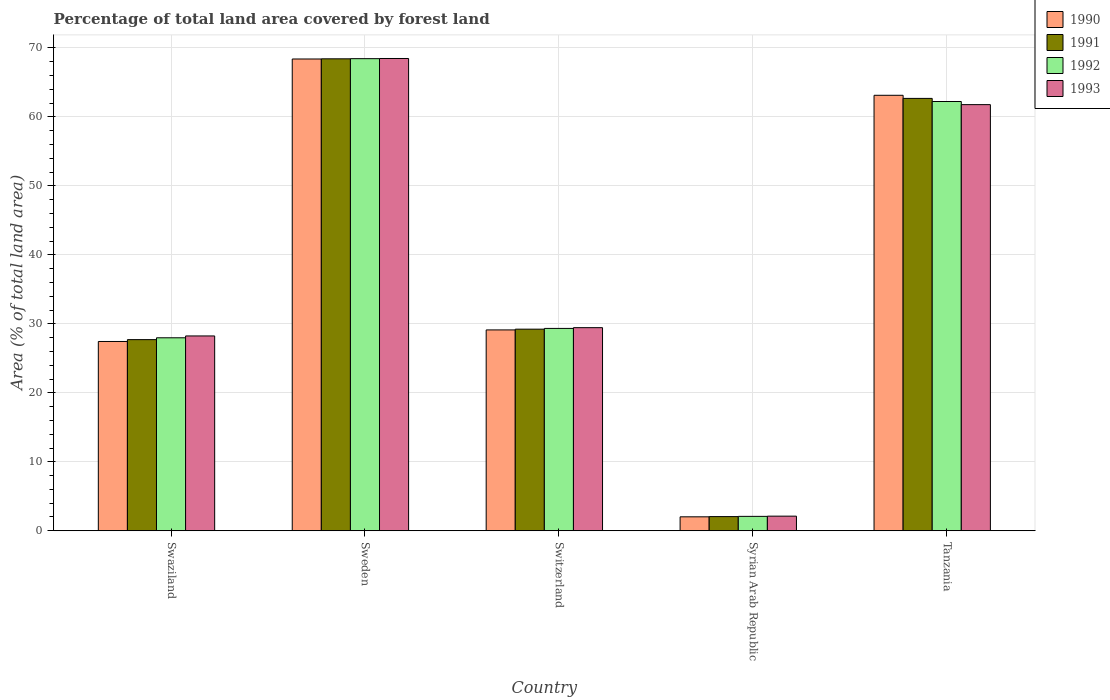How many different coloured bars are there?
Provide a succinct answer. 4. Are the number of bars per tick equal to the number of legend labels?
Offer a terse response. Yes. What is the label of the 2nd group of bars from the left?
Your answer should be compact. Sweden. In how many cases, is the number of bars for a given country not equal to the number of legend labels?
Provide a succinct answer. 0. What is the percentage of forest land in 1990 in Syrian Arab Republic?
Ensure brevity in your answer.  2.02. Across all countries, what is the maximum percentage of forest land in 1991?
Your response must be concise. 68.41. Across all countries, what is the minimum percentage of forest land in 1990?
Offer a terse response. 2.02. In which country was the percentage of forest land in 1993 minimum?
Give a very brief answer. Syrian Arab Republic. What is the total percentage of forest land in 1992 in the graph?
Your answer should be very brief. 190.07. What is the difference between the percentage of forest land in 1991 in Switzerland and that in Syrian Arab Republic?
Offer a very short reply. 27.17. What is the difference between the percentage of forest land in 1991 in Sweden and the percentage of forest land in 1990 in Switzerland?
Offer a very short reply. 39.3. What is the average percentage of forest land in 1990 per country?
Offer a very short reply. 38.02. What is the difference between the percentage of forest land of/in 1990 and percentage of forest land of/in 1992 in Swaziland?
Your response must be concise. -0.53. In how many countries, is the percentage of forest land in 1990 greater than 38 %?
Provide a short and direct response. 2. What is the ratio of the percentage of forest land in 1990 in Switzerland to that in Tanzania?
Your answer should be very brief. 0.46. Is the difference between the percentage of forest land in 1990 in Switzerland and Syrian Arab Republic greater than the difference between the percentage of forest land in 1992 in Switzerland and Syrian Arab Republic?
Your answer should be very brief. No. What is the difference between the highest and the second highest percentage of forest land in 1992?
Keep it short and to the point. 39.1. What is the difference between the highest and the lowest percentage of forest land in 1991?
Your answer should be compact. 66.36. Is it the case that in every country, the sum of the percentage of forest land in 1991 and percentage of forest land in 1993 is greater than the sum of percentage of forest land in 1990 and percentage of forest land in 1992?
Make the answer very short. No. What does the 2nd bar from the left in Tanzania represents?
Ensure brevity in your answer.  1991. What does the 2nd bar from the right in Syrian Arab Republic represents?
Your answer should be compact. 1992. Is it the case that in every country, the sum of the percentage of forest land in 1990 and percentage of forest land in 1991 is greater than the percentage of forest land in 1992?
Ensure brevity in your answer.  Yes. How many bars are there?
Keep it short and to the point. 20. How many countries are there in the graph?
Provide a succinct answer. 5. What is the difference between two consecutive major ticks on the Y-axis?
Make the answer very short. 10. Does the graph contain any zero values?
Offer a terse response. No. Where does the legend appear in the graph?
Your response must be concise. Top right. How are the legend labels stacked?
Provide a short and direct response. Vertical. What is the title of the graph?
Ensure brevity in your answer.  Percentage of total land area covered by forest land. What is the label or title of the X-axis?
Offer a very short reply. Country. What is the label or title of the Y-axis?
Provide a succinct answer. Area (% of total land area). What is the Area (% of total land area) in 1990 in Swaziland?
Ensure brevity in your answer.  27.44. What is the Area (% of total land area) of 1991 in Swaziland?
Give a very brief answer. 27.71. What is the Area (% of total land area) of 1992 in Swaziland?
Offer a very short reply. 27.98. What is the Area (% of total land area) of 1993 in Swaziland?
Your answer should be compact. 28.24. What is the Area (% of total land area) in 1990 in Sweden?
Offer a terse response. 68.39. What is the Area (% of total land area) of 1991 in Sweden?
Ensure brevity in your answer.  68.41. What is the Area (% of total land area) in 1992 in Sweden?
Keep it short and to the point. 68.44. What is the Area (% of total land area) in 1993 in Sweden?
Your answer should be very brief. 68.46. What is the Area (% of total land area) in 1990 in Switzerland?
Offer a very short reply. 29.12. What is the Area (% of total land area) of 1991 in Switzerland?
Your answer should be very brief. 29.23. What is the Area (% of total land area) in 1992 in Switzerland?
Your response must be concise. 29.34. What is the Area (% of total land area) of 1993 in Switzerland?
Offer a very short reply. 29.44. What is the Area (% of total land area) of 1990 in Syrian Arab Republic?
Provide a short and direct response. 2.02. What is the Area (% of total land area) of 1991 in Syrian Arab Republic?
Your answer should be compact. 2.06. What is the Area (% of total land area) of 1992 in Syrian Arab Republic?
Ensure brevity in your answer.  2.09. What is the Area (% of total land area) in 1993 in Syrian Arab Republic?
Offer a terse response. 2.12. What is the Area (% of total land area) of 1990 in Tanzania?
Offer a very short reply. 63.13. What is the Area (% of total land area) of 1991 in Tanzania?
Your response must be concise. 62.68. What is the Area (% of total land area) of 1992 in Tanzania?
Make the answer very short. 62.23. What is the Area (% of total land area) of 1993 in Tanzania?
Ensure brevity in your answer.  61.77. Across all countries, what is the maximum Area (% of total land area) of 1990?
Your answer should be compact. 68.39. Across all countries, what is the maximum Area (% of total land area) in 1991?
Your answer should be compact. 68.41. Across all countries, what is the maximum Area (% of total land area) in 1992?
Ensure brevity in your answer.  68.44. Across all countries, what is the maximum Area (% of total land area) of 1993?
Keep it short and to the point. 68.46. Across all countries, what is the minimum Area (% of total land area) of 1990?
Your answer should be very brief. 2.02. Across all countries, what is the minimum Area (% of total land area) in 1991?
Your answer should be compact. 2.06. Across all countries, what is the minimum Area (% of total land area) of 1992?
Offer a terse response. 2.09. Across all countries, what is the minimum Area (% of total land area) in 1993?
Your answer should be very brief. 2.12. What is the total Area (% of total land area) of 1990 in the graph?
Provide a succinct answer. 190.1. What is the total Area (% of total land area) of 1991 in the graph?
Ensure brevity in your answer.  190.08. What is the total Area (% of total land area) in 1992 in the graph?
Provide a short and direct response. 190.07. What is the total Area (% of total land area) in 1993 in the graph?
Your answer should be compact. 190.05. What is the difference between the Area (% of total land area) of 1990 in Swaziland and that in Sweden?
Your answer should be very brief. -40.95. What is the difference between the Area (% of total land area) of 1991 in Swaziland and that in Sweden?
Offer a terse response. -40.7. What is the difference between the Area (% of total land area) of 1992 in Swaziland and that in Sweden?
Offer a very short reply. -40.46. What is the difference between the Area (% of total land area) in 1993 in Swaziland and that in Sweden?
Provide a short and direct response. -40.22. What is the difference between the Area (% of total land area) of 1990 in Swaziland and that in Switzerland?
Provide a succinct answer. -1.68. What is the difference between the Area (% of total land area) of 1991 in Swaziland and that in Switzerland?
Offer a terse response. -1.52. What is the difference between the Area (% of total land area) of 1992 in Swaziland and that in Switzerland?
Your answer should be compact. -1.36. What is the difference between the Area (% of total land area) of 1993 in Swaziland and that in Switzerland?
Your answer should be very brief. -1.2. What is the difference between the Area (% of total land area) of 1990 in Swaziland and that in Syrian Arab Republic?
Your answer should be compact. 25.42. What is the difference between the Area (% of total land area) in 1991 in Swaziland and that in Syrian Arab Republic?
Give a very brief answer. 25.65. What is the difference between the Area (% of total land area) in 1992 in Swaziland and that in Syrian Arab Republic?
Your response must be concise. 25.89. What is the difference between the Area (% of total land area) of 1993 in Swaziland and that in Syrian Arab Republic?
Keep it short and to the point. 26.12. What is the difference between the Area (% of total land area) in 1990 in Swaziland and that in Tanzania?
Make the answer very short. -35.69. What is the difference between the Area (% of total land area) in 1991 in Swaziland and that in Tanzania?
Keep it short and to the point. -34.97. What is the difference between the Area (% of total land area) in 1992 in Swaziland and that in Tanzania?
Provide a short and direct response. -34.25. What is the difference between the Area (% of total land area) of 1993 in Swaziland and that in Tanzania?
Give a very brief answer. -33.53. What is the difference between the Area (% of total land area) of 1990 in Sweden and that in Switzerland?
Give a very brief answer. 39.27. What is the difference between the Area (% of total land area) in 1991 in Sweden and that in Switzerland?
Offer a terse response. 39.19. What is the difference between the Area (% of total land area) of 1992 in Sweden and that in Switzerland?
Provide a succinct answer. 39.1. What is the difference between the Area (% of total land area) of 1993 in Sweden and that in Switzerland?
Offer a very short reply. 39.02. What is the difference between the Area (% of total land area) in 1990 in Sweden and that in Syrian Arab Republic?
Provide a short and direct response. 66.37. What is the difference between the Area (% of total land area) of 1991 in Sweden and that in Syrian Arab Republic?
Provide a succinct answer. 66.36. What is the difference between the Area (% of total land area) of 1992 in Sweden and that in Syrian Arab Republic?
Keep it short and to the point. 66.35. What is the difference between the Area (% of total land area) in 1993 in Sweden and that in Syrian Arab Republic?
Your answer should be very brief. 66.34. What is the difference between the Area (% of total land area) of 1990 in Sweden and that in Tanzania?
Your response must be concise. 5.26. What is the difference between the Area (% of total land area) of 1991 in Sweden and that in Tanzania?
Provide a succinct answer. 5.74. What is the difference between the Area (% of total land area) in 1992 in Sweden and that in Tanzania?
Offer a terse response. 6.21. What is the difference between the Area (% of total land area) of 1993 in Sweden and that in Tanzania?
Ensure brevity in your answer.  6.69. What is the difference between the Area (% of total land area) of 1990 in Switzerland and that in Syrian Arab Republic?
Your answer should be very brief. 27.09. What is the difference between the Area (% of total land area) in 1991 in Switzerland and that in Syrian Arab Republic?
Provide a succinct answer. 27.17. What is the difference between the Area (% of total land area) of 1992 in Switzerland and that in Syrian Arab Republic?
Your answer should be very brief. 27.25. What is the difference between the Area (% of total land area) in 1993 in Switzerland and that in Syrian Arab Republic?
Keep it short and to the point. 27.32. What is the difference between the Area (% of total land area) of 1990 in Switzerland and that in Tanzania?
Provide a succinct answer. -34.01. What is the difference between the Area (% of total land area) in 1991 in Switzerland and that in Tanzania?
Offer a very short reply. -33.45. What is the difference between the Area (% of total land area) of 1992 in Switzerland and that in Tanzania?
Your answer should be compact. -32.89. What is the difference between the Area (% of total land area) of 1993 in Switzerland and that in Tanzania?
Keep it short and to the point. -32.33. What is the difference between the Area (% of total land area) of 1990 in Syrian Arab Republic and that in Tanzania?
Your answer should be very brief. -61.11. What is the difference between the Area (% of total land area) of 1991 in Syrian Arab Republic and that in Tanzania?
Your answer should be very brief. -60.62. What is the difference between the Area (% of total land area) of 1992 in Syrian Arab Republic and that in Tanzania?
Your response must be concise. -60.14. What is the difference between the Area (% of total land area) of 1993 in Syrian Arab Republic and that in Tanzania?
Make the answer very short. -59.65. What is the difference between the Area (% of total land area) in 1990 in Swaziland and the Area (% of total land area) in 1991 in Sweden?
Your answer should be very brief. -40.97. What is the difference between the Area (% of total land area) of 1990 in Swaziland and the Area (% of total land area) of 1992 in Sweden?
Keep it short and to the point. -41. What is the difference between the Area (% of total land area) in 1990 in Swaziland and the Area (% of total land area) in 1993 in Sweden?
Keep it short and to the point. -41.02. What is the difference between the Area (% of total land area) in 1991 in Swaziland and the Area (% of total land area) in 1992 in Sweden?
Give a very brief answer. -40.73. What is the difference between the Area (% of total land area) of 1991 in Swaziland and the Area (% of total land area) of 1993 in Sweden?
Give a very brief answer. -40.75. What is the difference between the Area (% of total land area) of 1992 in Swaziland and the Area (% of total land area) of 1993 in Sweden?
Make the answer very short. -40.49. What is the difference between the Area (% of total land area) of 1990 in Swaziland and the Area (% of total land area) of 1991 in Switzerland?
Ensure brevity in your answer.  -1.78. What is the difference between the Area (% of total land area) in 1990 in Swaziland and the Area (% of total land area) in 1992 in Switzerland?
Offer a terse response. -1.89. What is the difference between the Area (% of total land area) in 1990 in Swaziland and the Area (% of total land area) in 1993 in Switzerland?
Your response must be concise. -2. What is the difference between the Area (% of total land area) of 1991 in Swaziland and the Area (% of total land area) of 1992 in Switzerland?
Ensure brevity in your answer.  -1.63. What is the difference between the Area (% of total land area) in 1991 in Swaziland and the Area (% of total land area) in 1993 in Switzerland?
Provide a short and direct response. -1.73. What is the difference between the Area (% of total land area) in 1992 in Swaziland and the Area (% of total land area) in 1993 in Switzerland?
Your answer should be very brief. -1.47. What is the difference between the Area (% of total land area) of 1990 in Swaziland and the Area (% of total land area) of 1991 in Syrian Arab Republic?
Your answer should be very brief. 25.39. What is the difference between the Area (% of total land area) in 1990 in Swaziland and the Area (% of total land area) in 1992 in Syrian Arab Republic?
Your answer should be very brief. 25.35. What is the difference between the Area (% of total land area) of 1990 in Swaziland and the Area (% of total land area) of 1993 in Syrian Arab Republic?
Your answer should be very brief. 25.32. What is the difference between the Area (% of total land area) of 1991 in Swaziland and the Area (% of total land area) of 1992 in Syrian Arab Republic?
Keep it short and to the point. 25.62. What is the difference between the Area (% of total land area) in 1991 in Swaziland and the Area (% of total land area) in 1993 in Syrian Arab Republic?
Offer a terse response. 25.59. What is the difference between the Area (% of total land area) of 1992 in Swaziland and the Area (% of total land area) of 1993 in Syrian Arab Republic?
Offer a terse response. 25.85. What is the difference between the Area (% of total land area) of 1990 in Swaziland and the Area (% of total land area) of 1991 in Tanzania?
Give a very brief answer. -35.24. What is the difference between the Area (% of total land area) of 1990 in Swaziland and the Area (% of total land area) of 1992 in Tanzania?
Your response must be concise. -34.78. What is the difference between the Area (% of total land area) in 1990 in Swaziland and the Area (% of total land area) in 1993 in Tanzania?
Give a very brief answer. -34.33. What is the difference between the Area (% of total land area) in 1991 in Swaziland and the Area (% of total land area) in 1992 in Tanzania?
Your answer should be very brief. -34.52. What is the difference between the Area (% of total land area) of 1991 in Swaziland and the Area (% of total land area) of 1993 in Tanzania?
Your response must be concise. -34.07. What is the difference between the Area (% of total land area) of 1992 in Swaziland and the Area (% of total land area) of 1993 in Tanzania?
Provide a succinct answer. -33.8. What is the difference between the Area (% of total land area) of 1990 in Sweden and the Area (% of total land area) of 1991 in Switzerland?
Provide a short and direct response. 39.16. What is the difference between the Area (% of total land area) in 1990 in Sweden and the Area (% of total land area) in 1992 in Switzerland?
Keep it short and to the point. 39.05. What is the difference between the Area (% of total land area) in 1990 in Sweden and the Area (% of total land area) in 1993 in Switzerland?
Provide a short and direct response. 38.95. What is the difference between the Area (% of total land area) in 1991 in Sweden and the Area (% of total land area) in 1992 in Switzerland?
Offer a very short reply. 39.08. What is the difference between the Area (% of total land area) of 1991 in Sweden and the Area (% of total land area) of 1993 in Switzerland?
Give a very brief answer. 38.97. What is the difference between the Area (% of total land area) in 1992 in Sweden and the Area (% of total land area) in 1993 in Switzerland?
Your answer should be compact. 38.99. What is the difference between the Area (% of total land area) in 1990 in Sweden and the Area (% of total land area) in 1991 in Syrian Arab Republic?
Make the answer very short. 66.33. What is the difference between the Area (% of total land area) in 1990 in Sweden and the Area (% of total land area) in 1992 in Syrian Arab Republic?
Your answer should be compact. 66.3. What is the difference between the Area (% of total land area) of 1990 in Sweden and the Area (% of total land area) of 1993 in Syrian Arab Republic?
Keep it short and to the point. 66.27. What is the difference between the Area (% of total land area) of 1991 in Sweden and the Area (% of total land area) of 1992 in Syrian Arab Republic?
Provide a short and direct response. 66.32. What is the difference between the Area (% of total land area) of 1991 in Sweden and the Area (% of total land area) of 1993 in Syrian Arab Republic?
Ensure brevity in your answer.  66.29. What is the difference between the Area (% of total land area) in 1992 in Sweden and the Area (% of total land area) in 1993 in Syrian Arab Republic?
Give a very brief answer. 66.32. What is the difference between the Area (% of total land area) of 1990 in Sweden and the Area (% of total land area) of 1991 in Tanzania?
Ensure brevity in your answer.  5.71. What is the difference between the Area (% of total land area) in 1990 in Sweden and the Area (% of total land area) in 1992 in Tanzania?
Ensure brevity in your answer.  6.16. What is the difference between the Area (% of total land area) in 1990 in Sweden and the Area (% of total land area) in 1993 in Tanzania?
Provide a short and direct response. 6.62. What is the difference between the Area (% of total land area) in 1991 in Sweden and the Area (% of total land area) in 1992 in Tanzania?
Keep it short and to the point. 6.19. What is the difference between the Area (% of total land area) in 1991 in Sweden and the Area (% of total land area) in 1993 in Tanzania?
Provide a short and direct response. 6.64. What is the difference between the Area (% of total land area) of 1992 in Sweden and the Area (% of total land area) of 1993 in Tanzania?
Make the answer very short. 6.66. What is the difference between the Area (% of total land area) of 1990 in Switzerland and the Area (% of total land area) of 1991 in Syrian Arab Republic?
Offer a terse response. 27.06. What is the difference between the Area (% of total land area) of 1990 in Switzerland and the Area (% of total land area) of 1992 in Syrian Arab Republic?
Offer a terse response. 27.03. What is the difference between the Area (% of total land area) in 1990 in Switzerland and the Area (% of total land area) in 1993 in Syrian Arab Republic?
Ensure brevity in your answer.  27. What is the difference between the Area (% of total land area) of 1991 in Switzerland and the Area (% of total land area) of 1992 in Syrian Arab Republic?
Your response must be concise. 27.14. What is the difference between the Area (% of total land area) in 1991 in Switzerland and the Area (% of total land area) in 1993 in Syrian Arab Republic?
Your response must be concise. 27.1. What is the difference between the Area (% of total land area) in 1992 in Switzerland and the Area (% of total land area) in 1993 in Syrian Arab Republic?
Ensure brevity in your answer.  27.21. What is the difference between the Area (% of total land area) in 1990 in Switzerland and the Area (% of total land area) in 1991 in Tanzania?
Keep it short and to the point. -33.56. What is the difference between the Area (% of total land area) of 1990 in Switzerland and the Area (% of total land area) of 1992 in Tanzania?
Ensure brevity in your answer.  -33.11. What is the difference between the Area (% of total land area) of 1990 in Switzerland and the Area (% of total land area) of 1993 in Tanzania?
Your answer should be very brief. -32.66. What is the difference between the Area (% of total land area) in 1991 in Switzerland and the Area (% of total land area) in 1992 in Tanzania?
Provide a short and direct response. -33. What is the difference between the Area (% of total land area) of 1991 in Switzerland and the Area (% of total land area) of 1993 in Tanzania?
Provide a succinct answer. -32.55. What is the difference between the Area (% of total land area) of 1992 in Switzerland and the Area (% of total land area) of 1993 in Tanzania?
Your answer should be very brief. -32.44. What is the difference between the Area (% of total land area) in 1990 in Syrian Arab Republic and the Area (% of total land area) in 1991 in Tanzania?
Keep it short and to the point. -60.65. What is the difference between the Area (% of total land area) of 1990 in Syrian Arab Republic and the Area (% of total land area) of 1992 in Tanzania?
Your answer should be very brief. -60.2. What is the difference between the Area (% of total land area) in 1990 in Syrian Arab Republic and the Area (% of total land area) in 1993 in Tanzania?
Give a very brief answer. -59.75. What is the difference between the Area (% of total land area) in 1991 in Syrian Arab Republic and the Area (% of total land area) in 1992 in Tanzania?
Offer a terse response. -60.17. What is the difference between the Area (% of total land area) in 1991 in Syrian Arab Republic and the Area (% of total land area) in 1993 in Tanzania?
Your response must be concise. -59.72. What is the difference between the Area (% of total land area) in 1992 in Syrian Arab Republic and the Area (% of total land area) in 1993 in Tanzania?
Offer a very short reply. -59.69. What is the average Area (% of total land area) in 1990 per country?
Keep it short and to the point. 38.02. What is the average Area (% of total land area) in 1991 per country?
Provide a short and direct response. 38.02. What is the average Area (% of total land area) in 1992 per country?
Offer a very short reply. 38.01. What is the average Area (% of total land area) in 1993 per country?
Offer a terse response. 38.01. What is the difference between the Area (% of total land area) in 1990 and Area (% of total land area) in 1991 in Swaziland?
Keep it short and to the point. -0.27. What is the difference between the Area (% of total land area) in 1990 and Area (% of total land area) in 1992 in Swaziland?
Offer a terse response. -0.53. What is the difference between the Area (% of total land area) in 1990 and Area (% of total land area) in 1993 in Swaziland?
Provide a succinct answer. -0.8. What is the difference between the Area (% of total land area) of 1991 and Area (% of total land area) of 1992 in Swaziland?
Keep it short and to the point. -0.27. What is the difference between the Area (% of total land area) in 1991 and Area (% of total land area) in 1993 in Swaziland?
Offer a very short reply. -0.53. What is the difference between the Area (% of total land area) in 1992 and Area (% of total land area) in 1993 in Swaziland?
Make the answer very short. -0.27. What is the difference between the Area (% of total land area) in 1990 and Area (% of total land area) in 1991 in Sweden?
Provide a succinct answer. -0.02. What is the difference between the Area (% of total land area) in 1990 and Area (% of total land area) in 1992 in Sweden?
Provide a succinct answer. -0.05. What is the difference between the Area (% of total land area) of 1990 and Area (% of total land area) of 1993 in Sweden?
Ensure brevity in your answer.  -0.07. What is the difference between the Area (% of total land area) in 1991 and Area (% of total land area) in 1992 in Sweden?
Your answer should be very brief. -0.02. What is the difference between the Area (% of total land area) in 1991 and Area (% of total land area) in 1993 in Sweden?
Give a very brief answer. -0.05. What is the difference between the Area (% of total land area) of 1992 and Area (% of total land area) of 1993 in Sweden?
Keep it short and to the point. -0.02. What is the difference between the Area (% of total land area) of 1990 and Area (% of total land area) of 1991 in Switzerland?
Provide a short and direct response. -0.11. What is the difference between the Area (% of total land area) of 1990 and Area (% of total land area) of 1992 in Switzerland?
Offer a very short reply. -0.22. What is the difference between the Area (% of total land area) of 1990 and Area (% of total land area) of 1993 in Switzerland?
Your response must be concise. -0.33. What is the difference between the Area (% of total land area) in 1991 and Area (% of total land area) in 1992 in Switzerland?
Your answer should be compact. -0.11. What is the difference between the Area (% of total land area) in 1991 and Area (% of total land area) in 1993 in Switzerland?
Make the answer very short. -0.22. What is the difference between the Area (% of total land area) in 1992 and Area (% of total land area) in 1993 in Switzerland?
Make the answer very short. -0.11. What is the difference between the Area (% of total land area) of 1990 and Area (% of total land area) of 1991 in Syrian Arab Republic?
Your answer should be very brief. -0.03. What is the difference between the Area (% of total land area) of 1990 and Area (% of total land area) of 1992 in Syrian Arab Republic?
Offer a very short reply. -0.07. What is the difference between the Area (% of total land area) in 1990 and Area (% of total land area) in 1993 in Syrian Arab Republic?
Provide a short and direct response. -0.1. What is the difference between the Area (% of total land area) of 1991 and Area (% of total land area) of 1992 in Syrian Arab Republic?
Your answer should be compact. -0.03. What is the difference between the Area (% of total land area) of 1991 and Area (% of total land area) of 1993 in Syrian Arab Republic?
Your answer should be compact. -0.07. What is the difference between the Area (% of total land area) in 1992 and Area (% of total land area) in 1993 in Syrian Arab Republic?
Your answer should be compact. -0.03. What is the difference between the Area (% of total land area) of 1990 and Area (% of total land area) of 1991 in Tanzania?
Make the answer very short. 0.45. What is the difference between the Area (% of total land area) of 1990 and Area (% of total land area) of 1992 in Tanzania?
Offer a very short reply. 0.9. What is the difference between the Area (% of total land area) in 1990 and Area (% of total land area) in 1993 in Tanzania?
Offer a terse response. 1.35. What is the difference between the Area (% of total land area) in 1991 and Area (% of total land area) in 1992 in Tanzania?
Provide a succinct answer. 0.45. What is the difference between the Area (% of total land area) in 1991 and Area (% of total land area) in 1993 in Tanzania?
Offer a very short reply. 0.9. What is the difference between the Area (% of total land area) of 1992 and Area (% of total land area) of 1993 in Tanzania?
Give a very brief answer. 0.45. What is the ratio of the Area (% of total land area) in 1990 in Swaziland to that in Sweden?
Give a very brief answer. 0.4. What is the ratio of the Area (% of total land area) in 1991 in Swaziland to that in Sweden?
Offer a very short reply. 0.41. What is the ratio of the Area (% of total land area) in 1992 in Swaziland to that in Sweden?
Give a very brief answer. 0.41. What is the ratio of the Area (% of total land area) of 1993 in Swaziland to that in Sweden?
Provide a succinct answer. 0.41. What is the ratio of the Area (% of total land area) of 1990 in Swaziland to that in Switzerland?
Offer a very short reply. 0.94. What is the ratio of the Area (% of total land area) in 1991 in Swaziland to that in Switzerland?
Make the answer very short. 0.95. What is the ratio of the Area (% of total land area) in 1992 in Swaziland to that in Switzerland?
Make the answer very short. 0.95. What is the ratio of the Area (% of total land area) in 1993 in Swaziland to that in Switzerland?
Ensure brevity in your answer.  0.96. What is the ratio of the Area (% of total land area) in 1990 in Swaziland to that in Syrian Arab Republic?
Provide a succinct answer. 13.56. What is the ratio of the Area (% of total land area) of 1991 in Swaziland to that in Syrian Arab Republic?
Your response must be concise. 13.47. What is the ratio of the Area (% of total land area) in 1992 in Swaziland to that in Syrian Arab Republic?
Offer a very short reply. 13.39. What is the ratio of the Area (% of total land area) of 1993 in Swaziland to that in Syrian Arab Republic?
Your response must be concise. 13.31. What is the ratio of the Area (% of total land area) of 1990 in Swaziland to that in Tanzania?
Provide a short and direct response. 0.43. What is the ratio of the Area (% of total land area) of 1991 in Swaziland to that in Tanzania?
Give a very brief answer. 0.44. What is the ratio of the Area (% of total land area) in 1992 in Swaziland to that in Tanzania?
Provide a succinct answer. 0.45. What is the ratio of the Area (% of total land area) in 1993 in Swaziland to that in Tanzania?
Ensure brevity in your answer.  0.46. What is the ratio of the Area (% of total land area) in 1990 in Sweden to that in Switzerland?
Offer a very short reply. 2.35. What is the ratio of the Area (% of total land area) in 1991 in Sweden to that in Switzerland?
Offer a terse response. 2.34. What is the ratio of the Area (% of total land area) of 1992 in Sweden to that in Switzerland?
Offer a terse response. 2.33. What is the ratio of the Area (% of total land area) in 1993 in Sweden to that in Switzerland?
Provide a short and direct response. 2.33. What is the ratio of the Area (% of total land area) in 1990 in Sweden to that in Syrian Arab Republic?
Ensure brevity in your answer.  33.79. What is the ratio of the Area (% of total land area) in 1991 in Sweden to that in Syrian Arab Republic?
Offer a very short reply. 33.26. What is the ratio of the Area (% of total land area) in 1992 in Sweden to that in Syrian Arab Republic?
Give a very brief answer. 32.75. What is the ratio of the Area (% of total land area) of 1993 in Sweden to that in Syrian Arab Republic?
Your answer should be compact. 32.26. What is the ratio of the Area (% of total land area) in 1991 in Sweden to that in Tanzania?
Provide a succinct answer. 1.09. What is the ratio of the Area (% of total land area) of 1992 in Sweden to that in Tanzania?
Make the answer very short. 1.1. What is the ratio of the Area (% of total land area) of 1993 in Sweden to that in Tanzania?
Your response must be concise. 1.11. What is the ratio of the Area (% of total land area) in 1990 in Switzerland to that in Syrian Arab Republic?
Your response must be concise. 14.39. What is the ratio of the Area (% of total land area) of 1991 in Switzerland to that in Syrian Arab Republic?
Ensure brevity in your answer.  14.21. What is the ratio of the Area (% of total land area) of 1992 in Switzerland to that in Syrian Arab Republic?
Keep it short and to the point. 14.04. What is the ratio of the Area (% of total land area) of 1993 in Switzerland to that in Syrian Arab Republic?
Give a very brief answer. 13.88. What is the ratio of the Area (% of total land area) in 1990 in Switzerland to that in Tanzania?
Keep it short and to the point. 0.46. What is the ratio of the Area (% of total land area) in 1991 in Switzerland to that in Tanzania?
Offer a very short reply. 0.47. What is the ratio of the Area (% of total land area) in 1992 in Switzerland to that in Tanzania?
Give a very brief answer. 0.47. What is the ratio of the Area (% of total land area) in 1993 in Switzerland to that in Tanzania?
Provide a short and direct response. 0.48. What is the ratio of the Area (% of total land area) of 1990 in Syrian Arab Republic to that in Tanzania?
Give a very brief answer. 0.03. What is the ratio of the Area (% of total land area) in 1991 in Syrian Arab Republic to that in Tanzania?
Offer a terse response. 0.03. What is the ratio of the Area (% of total land area) of 1992 in Syrian Arab Republic to that in Tanzania?
Provide a succinct answer. 0.03. What is the ratio of the Area (% of total land area) of 1993 in Syrian Arab Republic to that in Tanzania?
Keep it short and to the point. 0.03. What is the difference between the highest and the second highest Area (% of total land area) in 1990?
Give a very brief answer. 5.26. What is the difference between the highest and the second highest Area (% of total land area) of 1991?
Your response must be concise. 5.74. What is the difference between the highest and the second highest Area (% of total land area) in 1992?
Offer a terse response. 6.21. What is the difference between the highest and the second highest Area (% of total land area) in 1993?
Offer a terse response. 6.69. What is the difference between the highest and the lowest Area (% of total land area) of 1990?
Give a very brief answer. 66.37. What is the difference between the highest and the lowest Area (% of total land area) in 1991?
Make the answer very short. 66.36. What is the difference between the highest and the lowest Area (% of total land area) in 1992?
Make the answer very short. 66.35. What is the difference between the highest and the lowest Area (% of total land area) in 1993?
Provide a succinct answer. 66.34. 